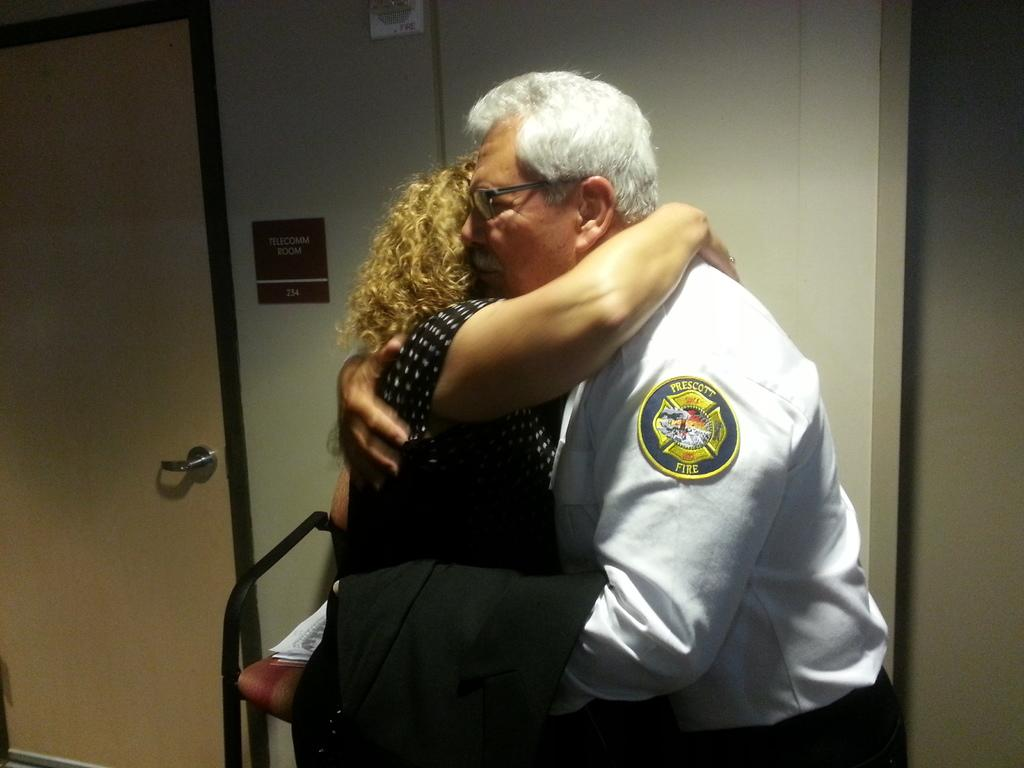How many people are present in the image? There are two people, a man and a woman, present in the image. What are the man and woman doing in the image? The man and woman are hugging each other in the image. What can be seen in the background of the image? There is a wall and a door in the background of the image. What type of plastic material is being stretched by the man in the image? There is no plastic material being stretched in the image; the man and woman are hugging each other. 